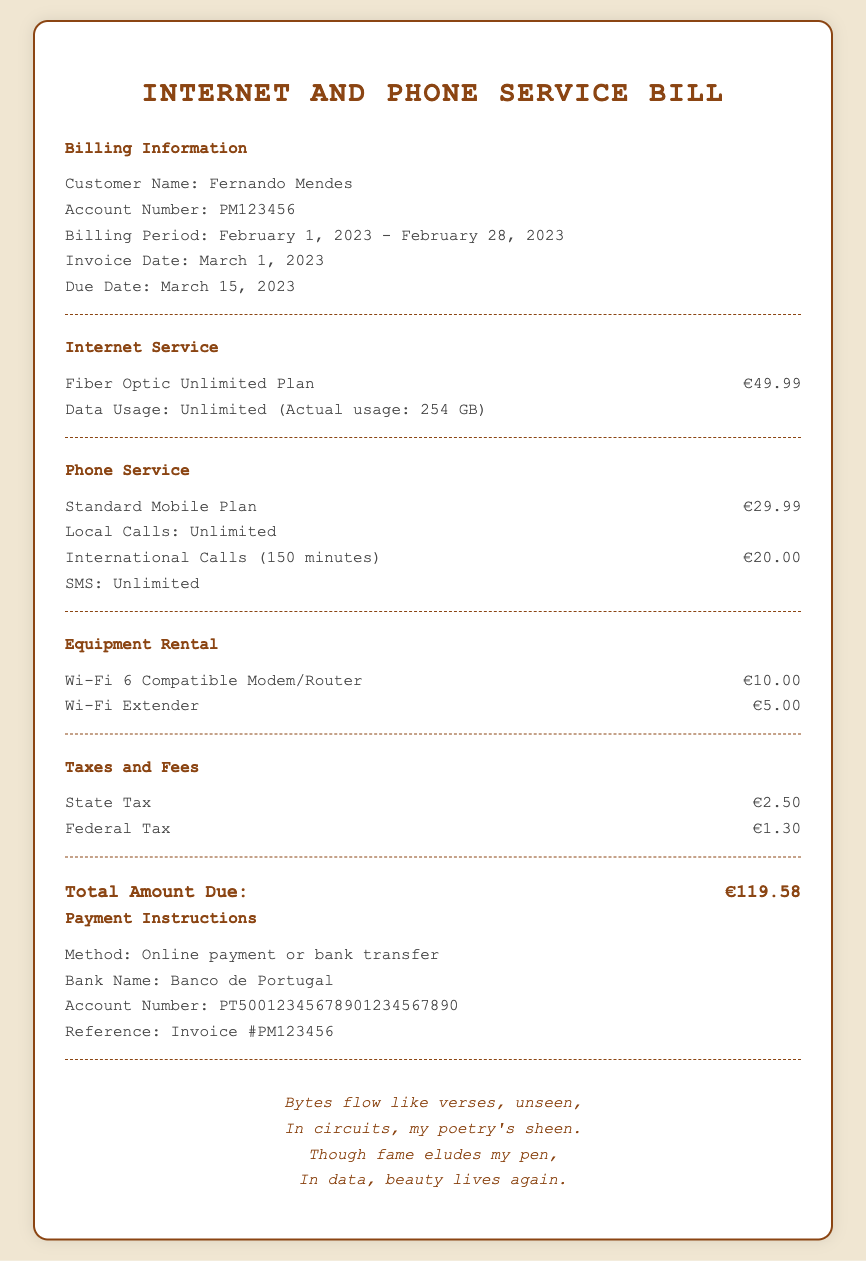What is the customer's name? The customer's name is clearly stated in the billing information section of the document.
Answer: Fernando Mendes What is the account number? The account number is listed under the billing information section.
Answer: PM123456 What is the due date for the bill? The due date is specified in the billing information section as the date by which payment is required.
Answer: March 15, 2023 What is the charge for the Fiber Optic Unlimited Plan? The charge for the internet service is given alongside the plan details in the document.
Answer: €49.99 How much did the international calls cost? The cost for international calls is explicitly stated in the phone service section of the bill.
Answer: €20.00 What is the total amount due? The total amount due sums all charges listed in the document, making it the final amount payable.
Answer: €119.58 What type of modem/router is rented? The document specifies the type of modem/router rented under the equipment rental section.
Answer: Wi-Fi 6 Compatible Modem/Router What are the payment instructions? The payment instructions include relevant details on how to pay the bill, which is detailed in a specific section.
Answer: Online payment or bank transfer What taxes are listed in the bill? The document includes a specific section outlining the taxes and fees charged, detailing each one separately.
Answer: State Tax and Federal Tax 